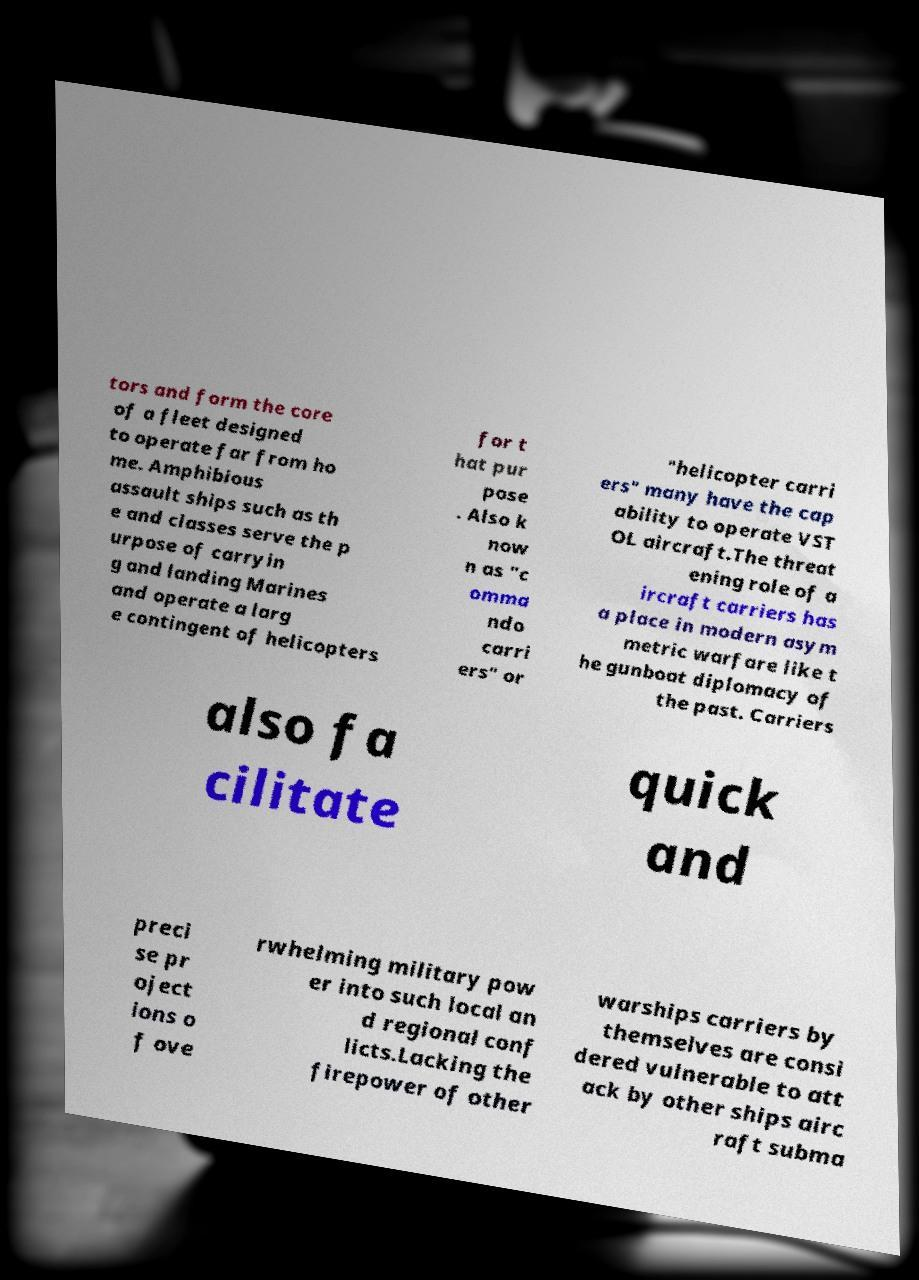Can you accurately transcribe the text from the provided image for me? tors and form the core of a fleet designed to operate far from ho me. Amphibious assault ships such as th e and classes serve the p urpose of carryin g and landing Marines and operate a larg e contingent of helicopters for t hat pur pose . Also k now n as "c omma ndo carri ers" or "helicopter carri ers" many have the cap ability to operate VST OL aircraft.The threat ening role of a ircraft carriers has a place in modern asym metric warfare like t he gunboat diplomacy of the past. Carriers also fa cilitate quick and preci se pr oject ions o f ove rwhelming military pow er into such local an d regional conf licts.Lacking the firepower of other warships carriers by themselves are consi dered vulnerable to att ack by other ships airc raft subma 